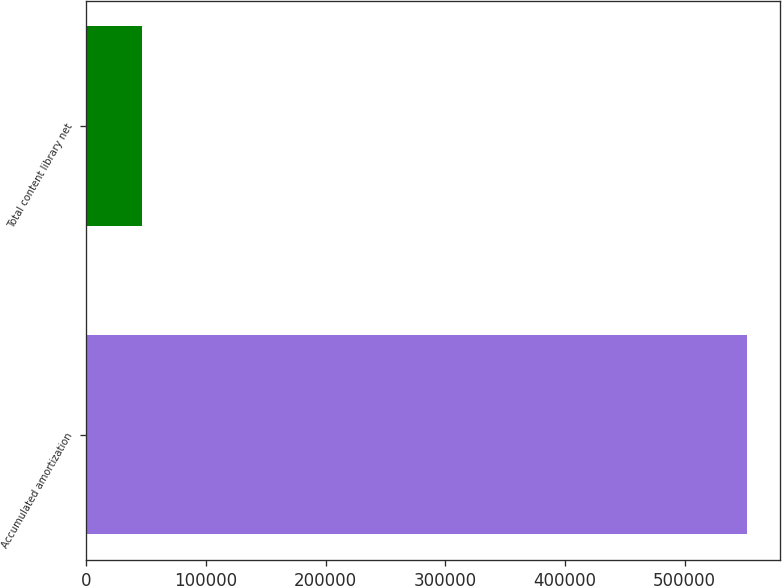Convert chart to OTSL. <chart><loc_0><loc_0><loc_500><loc_500><bar_chart><fcel>Accumulated amortization<fcel>Total content library net<nl><fcel>552526<fcel>46629<nl></chart> 